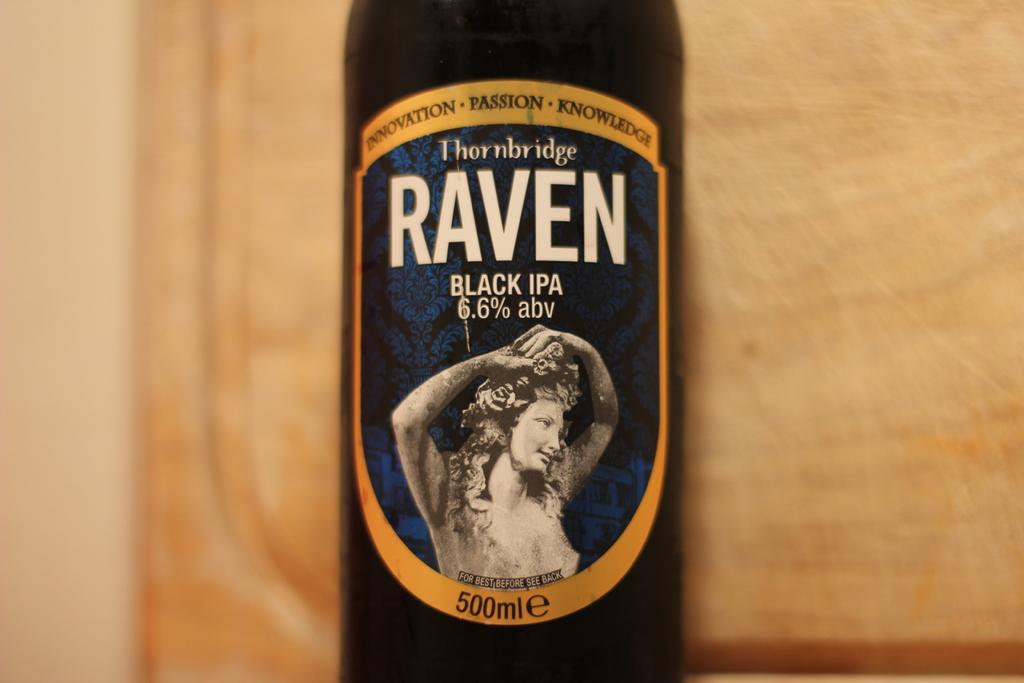What is the name of the drink's brand?
Offer a terse response. Thornbridge. What type of beer is this?
Your answer should be very brief. Black ipa. 